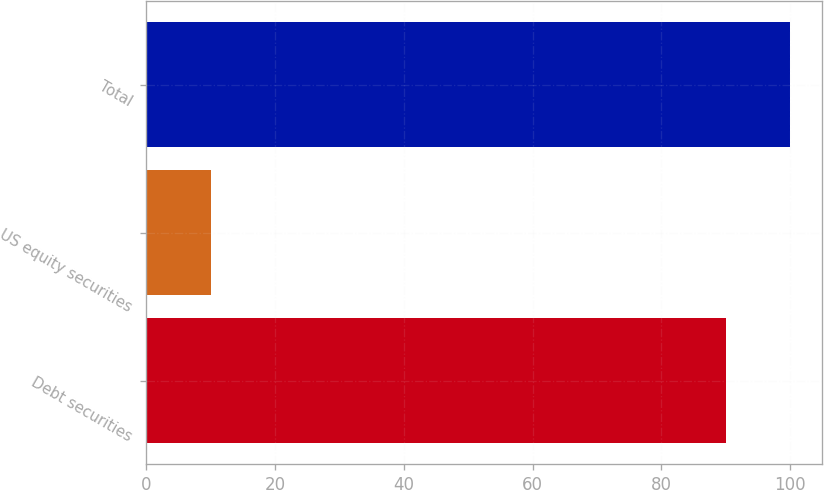<chart> <loc_0><loc_0><loc_500><loc_500><bar_chart><fcel>Debt securities<fcel>US equity securities<fcel>Total<nl><fcel>90<fcel>10<fcel>100<nl></chart> 